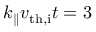<formula> <loc_0><loc_0><loc_500><loc_500>k _ { \| } v _ { t h , i } t = 3</formula> 